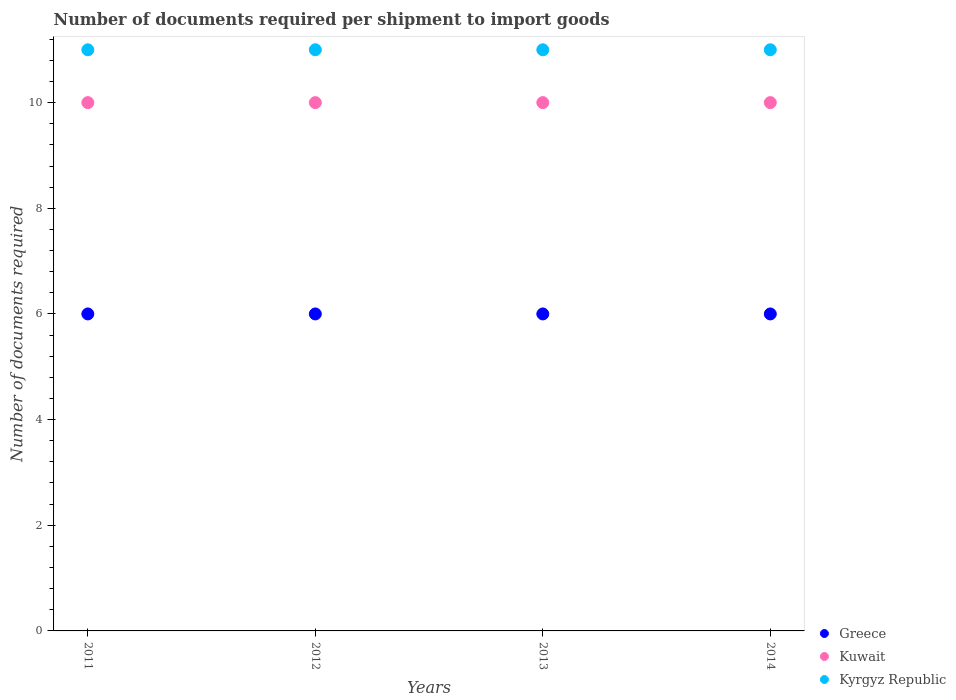Is the number of dotlines equal to the number of legend labels?
Provide a succinct answer. Yes. Across all years, what is the maximum number of documents required per shipment to import goods in Kyrgyz Republic?
Provide a succinct answer. 11. Across all years, what is the minimum number of documents required per shipment to import goods in Kuwait?
Your response must be concise. 10. In which year was the number of documents required per shipment to import goods in Kuwait maximum?
Provide a succinct answer. 2011. What is the total number of documents required per shipment to import goods in Kyrgyz Republic in the graph?
Provide a succinct answer. 44. What is the difference between the number of documents required per shipment to import goods in Kyrgyz Republic in 2012 and that in 2013?
Your response must be concise. 0. What is the difference between the number of documents required per shipment to import goods in Kyrgyz Republic in 2011 and the number of documents required per shipment to import goods in Greece in 2014?
Make the answer very short. 5. In the year 2012, what is the difference between the number of documents required per shipment to import goods in Kuwait and number of documents required per shipment to import goods in Greece?
Make the answer very short. 4. What is the ratio of the number of documents required per shipment to import goods in Kuwait in 2011 to that in 2014?
Provide a succinct answer. 1. What is the difference between the highest and the lowest number of documents required per shipment to import goods in Kuwait?
Provide a succinct answer. 0. In how many years, is the number of documents required per shipment to import goods in Kuwait greater than the average number of documents required per shipment to import goods in Kuwait taken over all years?
Make the answer very short. 0. Is the sum of the number of documents required per shipment to import goods in Kuwait in 2011 and 2013 greater than the maximum number of documents required per shipment to import goods in Greece across all years?
Keep it short and to the point. Yes. Is the number of documents required per shipment to import goods in Kuwait strictly less than the number of documents required per shipment to import goods in Greece over the years?
Your response must be concise. No. How many dotlines are there?
Give a very brief answer. 3. Does the graph contain any zero values?
Offer a very short reply. No. Does the graph contain grids?
Your answer should be compact. No. How many legend labels are there?
Your answer should be compact. 3. How are the legend labels stacked?
Make the answer very short. Vertical. What is the title of the graph?
Ensure brevity in your answer.  Number of documents required per shipment to import goods. What is the label or title of the Y-axis?
Offer a very short reply. Number of documents required. What is the Number of documents required of Kuwait in 2012?
Offer a terse response. 10. What is the Number of documents required of Kyrgyz Republic in 2012?
Make the answer very short. 11. What is the Number of documents required of Greece in 2013?
Give a very brief answer. 6. What is the Number of documents required of Kuwait in 2013?
Give a very brief answer. 10. What is the Number of documents required in Greece in 2014?
Your answer should be very brief. 6. What is the Number of documents required of Kuwait in 2014?
Provide a succinct answer. 10. Across all years, what is the maximum Number of documents required of Kuwait?
Your answer should be very brief. 10. Across all years, what is the minimum Number of documents required of Greece?
Provide a short and direct response. 6. Across all years, what is the minimum Number of documents required in Kuwait?
Ensure brevity in your answer.  10. Across all years, what is the minimum Number of documents required of Kyrgyz Republic?
Ensure brevity in your answer.  11. What is the total Number of documents required of Greece in the graph?
Your answer should be compact. 24. What is the total Number of documents required of Kuwait in the graph?
Keep it short and to the point. 40. What is the difference between the Number of documents required in Greece in 2011 and that in 2012?
Give a very brief answer. 0. What is the difference between the Number of documents required in Greece in 2011 and that in 2013?
Your answer should be compact. 0. What is the difference between the Number of documents required in Greece in 2011 and that in 2014?
Offer a very short reply. 0. What is the difference between the Number of documents required in Kuwait in 2011 and that in 2014?
Your answer should be very brief. 0. What is the difference between the Number of documents required in Greece in 2012 and that in 2013?
Provide a short and direct response. 0. What is the difference between the Number of documents required of Greece in 2012 and that in 2014?
Make the answer very short. 0. What is the difference between the Number of documents required of Kuwait in 2013 and that in 2014?
Keep it short and to the point. 0. What is the difference between the Number of documents required in Kuwait in 2011 and the Number of documents required in Kyrgyz Republic in 2012?
Make the answer very short. -1. What is the difference between the Number of documents required of Greece in 2011 and the Number of documents required of Kyrgyz Republic in 2014?
Make the answer very short. -5. What is the difference between the Number of documents required of Greece in 2012 and the Number of documents required of Kuwait in 2013?
Offer a terse response. -4. What is the difference between the Number of documents required in Greece in 2012 and the Number of documents required in Kuwait in 2014?
Offer a terse response. -4. What is the difference between the Number of documents required in Kuwait in 2012 and the Number of documents required in Kyrgyz Republic in 2014?
Your answer should be compact. -1. What is the average Number of documents required in Greece per year?
Keep it short and to the point. 6. In the year 2011, what is the difference between the Number of documents required in Greece and Number of documents required in Kuwait?
Your response must be concise. -4. In the year 2011, what is the difference between the Number of documents required of Kuwait and Number of documents required of Kyrgyz Republic?
Your answer should be compact. -1. In the year 2012, what is the difference between the Number of documents required in Greece and Number of documents required in Kuwait?
Give a very brief answer. -4. In the year 2012, what is the difference between the Number of documents required in Kuwait and Number of documents required in Kyrgyz Republic?
Your answer should be very brief. -1. In the year 2013, what is the difference between the Number of documents required in Greece and Number of documents required in Kuwait?
Your response must be concise. -4. In the year 2013, what is the difference between the Number of documents required of Kuwait and Number of documents required of Kyrgyz Republic?
Keep it short and to the point. -1. In the year 2014, what is the difference between the Number of documents required in Greece and Number of documents required in Kuwait?
Your answer should be compact. -4. In the year 2014, what is the difference between the Number of documents required in Kuwait and Number of documents required in Kyrgyz Republic?
Make the answer very short. -1. What is the ratio of the Number of documents required in Greece in 2011 to that in 2012?
Give a very brief answer. 1. What is the ratio of the Number of documents required in Kyrgyz Republic in 2011 to that in 2012?
Make the answer very short. 1. What is the ratio of the Number of documents required in Greece in 2011 to that in 2013?
Offer a very short reply. 1. What is the ratio of the Number of documents required of Kuwait in 2011 to that in 2014?
Offer a very short reply. 1. What is the ratio of the Number of documents required in Kyrgyz Republic in 2011 to that in 2014?
Keep it short and to the point. 1. What is the ratio of the Number of documents required in Greece in 2012 to that in 2013?
Offer a terse response. 1. What is the ratio of the Number of documents required of Greece in 2012 to that in 2014?
Provide a short and direct response. 1. What is the ratio of the Number of documents required in Kuwait in 2012 to that in 2014?
Your answer should be compact. 1. What is the ratio of the Number of documents required in Greece in 2013 to that in 2014?
Your answer should be very brief. 1. What is the difference between the highest and the lowest Number of documents required of Greece?
Provide a short and direct response. 0. 